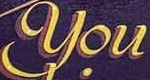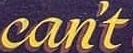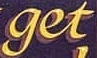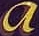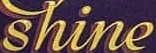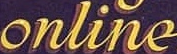Read the text from these images in sequence, separated by a semicolon. You; can't; get; a; shine; online 